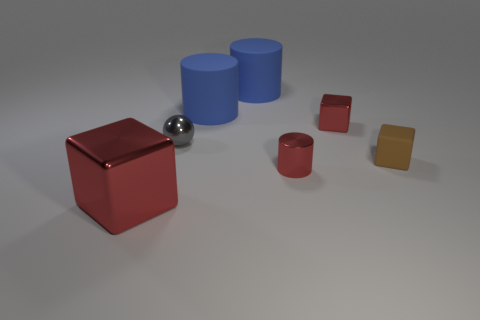Subtract 1 cylinders. How many cylinders are left? 2 Add 3 gray balls. How many objects exist? 10 Subtract all cubes. How many objects are left? 4 Subtract all small gray spheres. Subtract all big rubber cylinders. How many objects are left? 4 Add 4 tiny cylinders. How many tiny cylinders are left? 5 Add 1 tiny gray metallic blocks. How many tiny gray metallic blocks exist? 1 Subtract 0 purple blocks. How many objects are left? 7 